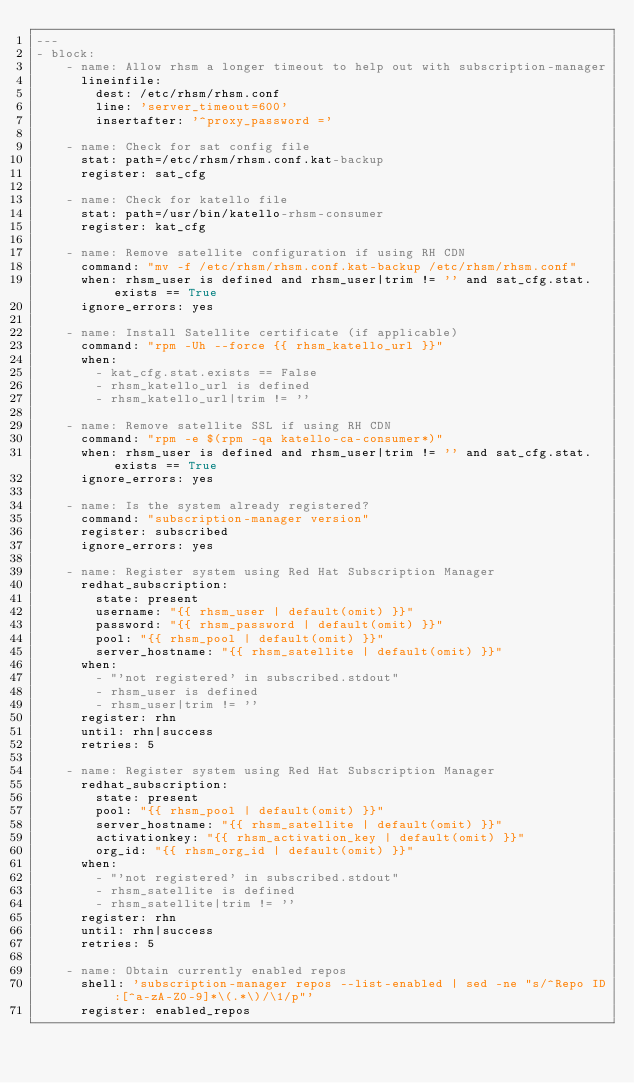<code> <loc_0><loc_0><loc_500><loc_500><_YAML_>---
- block:
    - name: Allow rhsm a longer timeout to help out with subscription-manager
      lineinfile:
        dest: /etc/rhsm/rhsm.conf
        line: 'server_timeout=600'
        insertafter: '^proxy_password ='

    - name: Check for sat config file
      stat: path=/etc/rhsm/rhsm.conf.kat-backup
      register: sat_cfg

    - name: Check for katello file
      stat: path=/usr/bin/katello-rhsm-consumer
      register: kat_cfg

    - name: Remove satellite configuration if using RH CDN
      command: "mv -f /etc/rhsm/rhsm.conf.kat-backup /etc/rhsm/rhsm.conf"
      when: rhsm_user is defined and rhsm_user|trim != '' and sat_cfg.stat.exists == True
      ignore_errors: yes

    - name: Install Satellite certificate (if applicable)
      command: "rpm -Uh --force {{ rhsm_katello_url }}"
      when:
        - kat_cfg.stat.exists == False
        - rhsm_katello_url is defined
        - rhsm_katello_url|trim != ''

    - name: Remove satellite SSL if using RH CDN
      command: "rpm -e $(rpm -qa katello-ca-consumer*)"
      when: rhsm_user is defined and rhsm_user|trim != '' and sat_cfg.stat.exists == True
      ignore_errors: yes

    - name: Is the system already registered?
      command: "subscription-manager version"
      register: subscribed
      ignore_errors: yes

    - name: Register system using Red Hat Subscription Manager
      redhat_subscription:
        state: present
        username: "{{ rhsm_user | default(omit) }}"
        password: "{{ rhsm_password | default(omit) }}"
        pool: "{{ rhsm_pool | default(omit) }}"
        server_hostname: "{{ rhsm_satellite | default(omit) }}"
      when:
        - "'not registered' in subscribed.stdout"
        - rhsm_user is defined
        - rhsm_user|trim != ''
      register: rhn
      until: rhn|success
      retries: 5

    - name: Register system using Red Hat Subscription Manager
      redhat_subscription:
        state: present
        pool: "{{ rhsm_pool | default(omit) }}"
        server_hostname: "{{ rhsm_satellite | default(omit) }}"
        activationkey: "{{ rhsm_activation_key | default(omit) }}"
        org_id: "{{ rhsm_org_id | default(omit) }}"
      when:
        - "'not registered' in subscribed.stdout"
        - rhsm_satellite is defined
        - rhsm_satellite|trim != ''
      register: rhn
      until: rhn|success
      retries: 5

    - name: Obtain currently enabled repos
      shell: 'subscription-manager repos --list-enabled | sed -ne "s/^Repo ID:[^a-zA-Z0-9]*\(.*\)/\1/p"'
      register: enabled_repos
</code> 